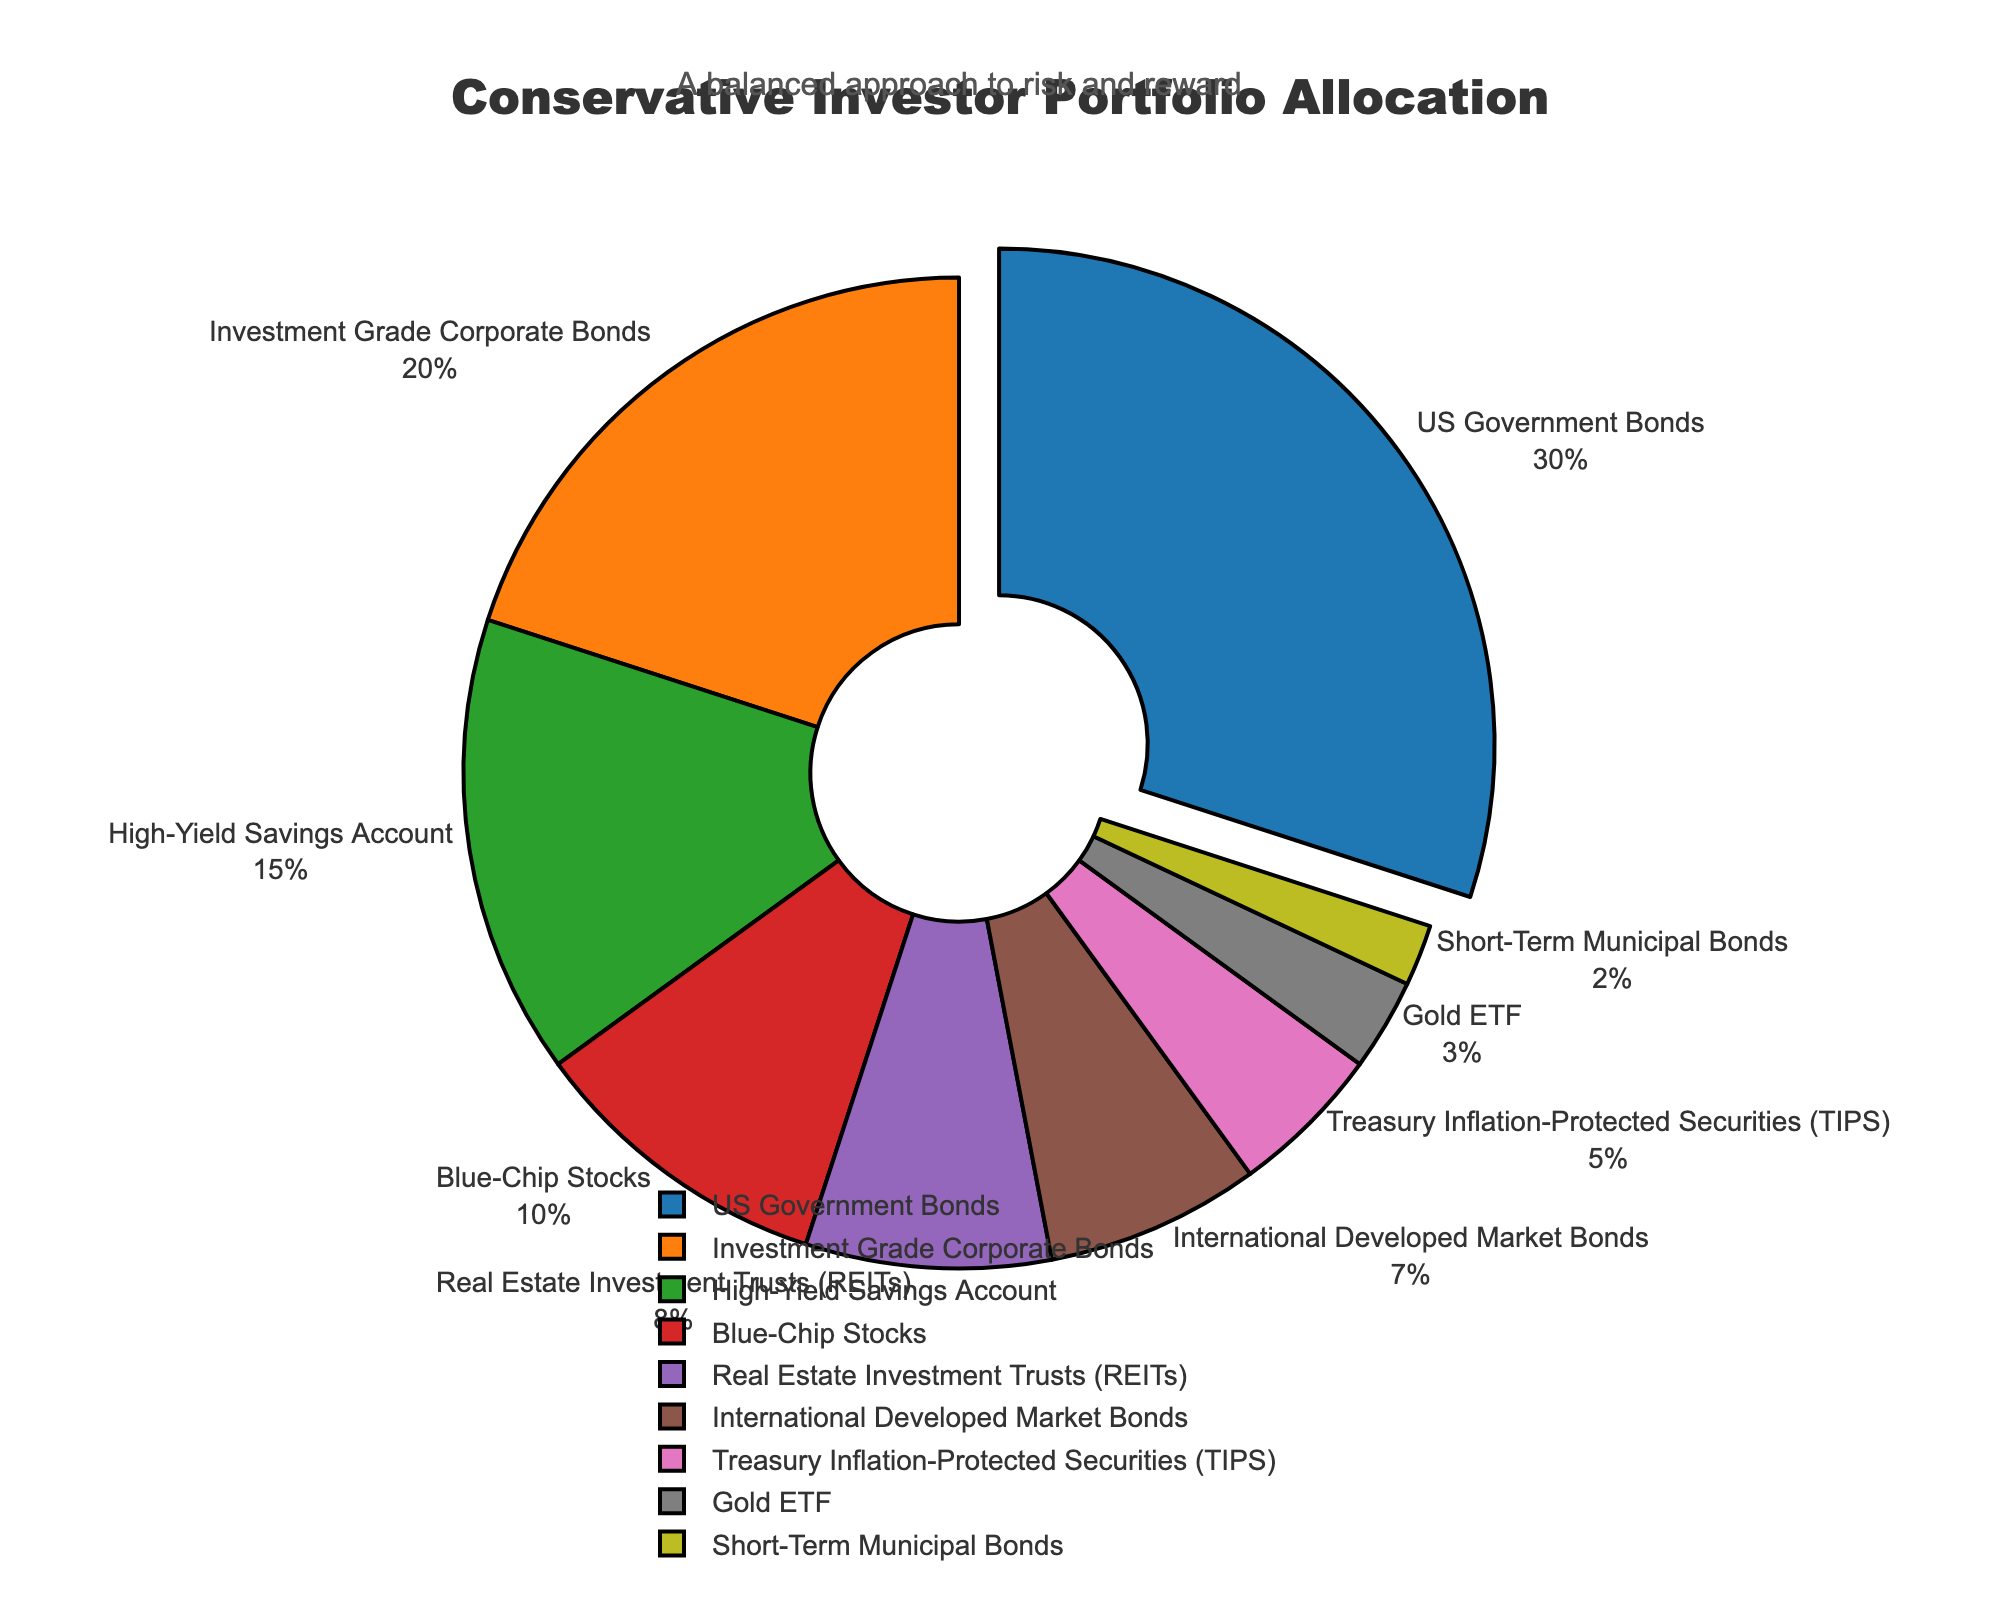Which asset class has the highest allocation percentage? The asset class with the highest allocation percentage is represented by the largest sector in the pie chart.
Answer: US Government Bonds What is the combined percentage of High-Yield Savings Account and Blue-Chip Stocks? To find the combined percentage of High-Yield Savings Account and Blue-Chip Stocks, add their individual percentages: 15% + 10%.
Answer: 25% Which asset class has the smallest allocation in the portfolio? The asset class with the smallest allocation is represented by the smallest sector in the pie chart.
Answer: Short-Term Municipal Bonds Is the percentage of Investment Grade Corporate Bonds higher than Real Estate Investment Trusts (REITs)? Compare the percentages of Investment Grade Corporate Bonds (20%) and Real Estate Investment Trusts (8%).
Answer: Yes What is the difference in percentage allocation between US Government Bonds and International Developed Market Bonds? Subtract the percentage of International Developed Market Bonds (7%) from the percentage of US Government Bonds (30%).
Answer: 23% How many asset classes have an allocation percentage of 10% or higher? Count the asset classes with percentages 10 or higher: US Government Bonds (30%), Investment Grade Corporate Bonds (20%), High-Yield Savings Account (15%), Blue-Chip Stocks (10%).
Answer: 4 Which sector is highlighted in the pie chart and why? The highlighted sector is the one with the highest percentage allocation and is slightly pulled out from the pie chart.
Answer: US Government Bonds What is the combined allocation for all bond-related asset classes in the portfolio? Add the percentages of US Government Bonds (30%), Investment Grade Corporate Bonds (20%), International Developed Market Bonds (7%), and Short-Term Municipal Bonds (2%).
Answer: 59% Is the allocation percentage of Gold ETF greater than or equal to Treasury Inflation-Protected Securities (TIPS)? Compare the percentages of Gold ETF (3%) and Treasury Inflation-Protected Securities (5%).
Answer: No What visual elements emphasize the title and the theme of the pie chart? The title is centrally aligned, bold, and in a larger font size. Annotations above the chart also contribute to the visual emphasis.
Answer: Central title and annotation 